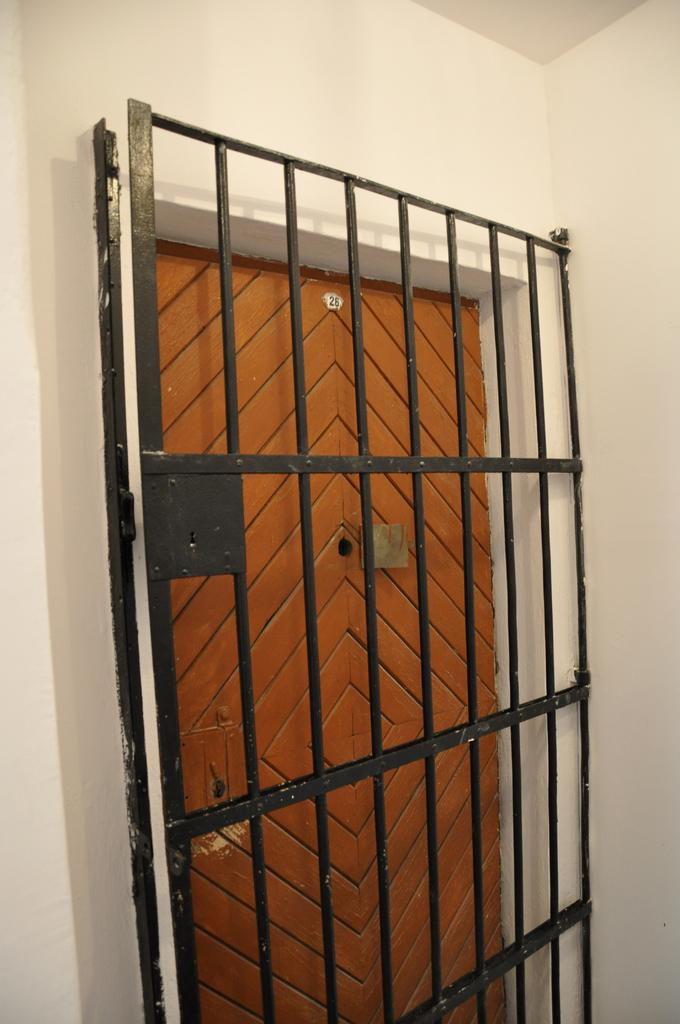What type of structure can be seen in the image? There is a metal frame in the image. What part of the structure is visible in the image? There is a door in the image. How is the door connected to the rest of the structure? The door is connected to a wall. What type of toothpaste is being used by the horses in the image? There are no horses or toothpaste present in the image. 